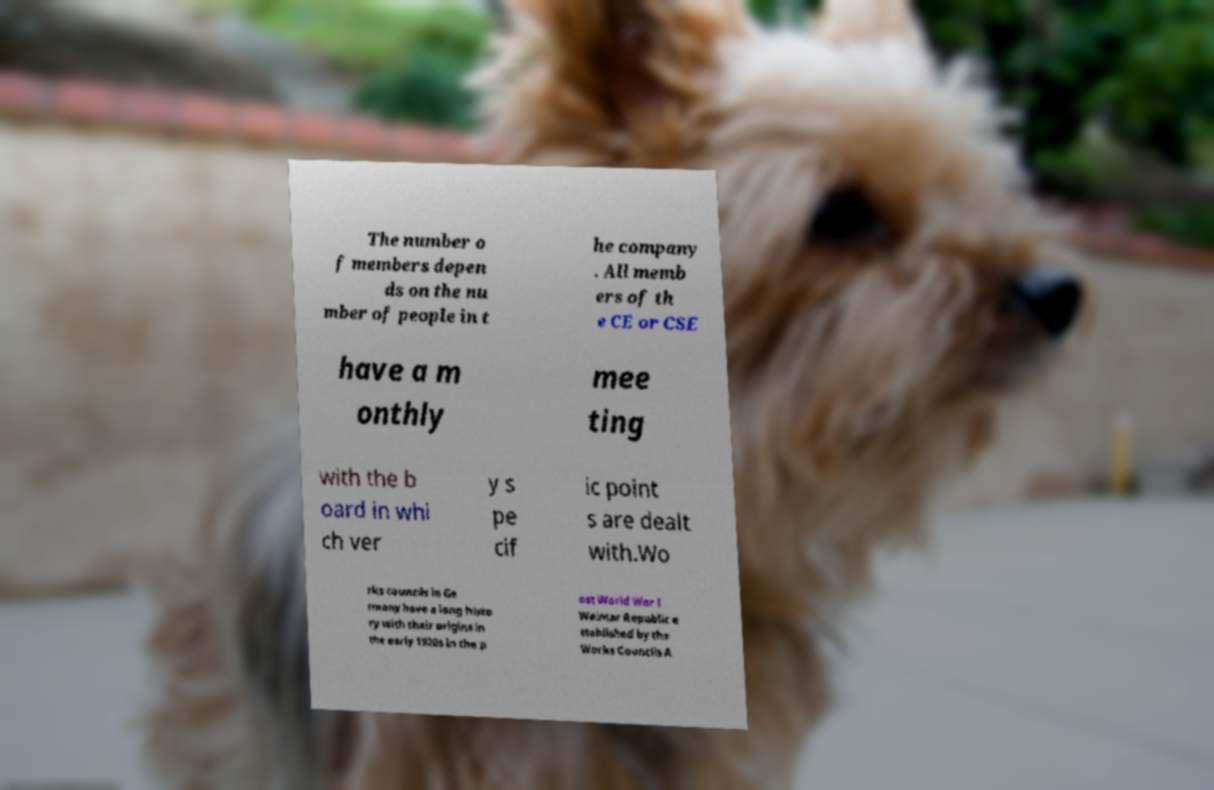Please read and relay the text visible in this image. What does it say? The number o f members depen ds on the nu mber of people in t he company . All memb ers of th e CE or CSE have a m onthly mee ting with the b oard in whi ch ver y s pe cif ic point s are dealt with.Wo rks councils in Ge rmany have a long histo ry with their origins in the early 1920s in the p ost World War I Weimar Republic e stablished by the Works Councils A 